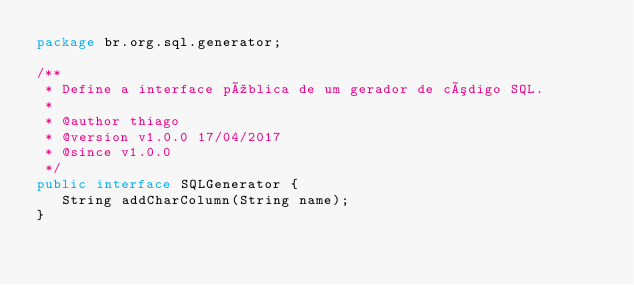<code> <loc_0><loc_0><loc_500><loc_500><_Java_>package br.org.sql.generator;

/**
 * Define a interface pública de um gerador de código SQL.
 * 
 * @author thiago
 * @version v1.0.0 17/04/2017
 * @since v1.0.0
 */
public interface SQLGenerator {
   String addCharColumn(String name);
}
</code> 